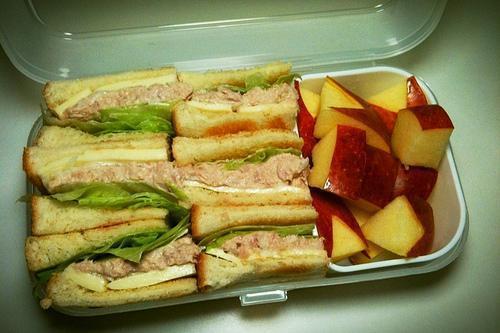How many pieces of sandwich are in the photo?
Give a very brief answer. 6. How many sandwiches are there?
Give a very brief answer. 8. How many people are in this photo?
Give a very brief answer. 0. 